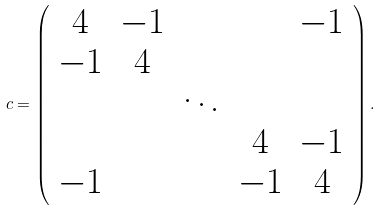<formula> <loc_0><loc_0><loc_500><loc_500>c = \left ( \begin{array} { c c c c c } 4 & - 1 & & & - 1 \\ - 1 & 4 & & & \\ & & \ddots & & \\ & & & 4 & - 1 \\ - 1 & & & - 1 & 4 \end{array} \right ) .</formula> 